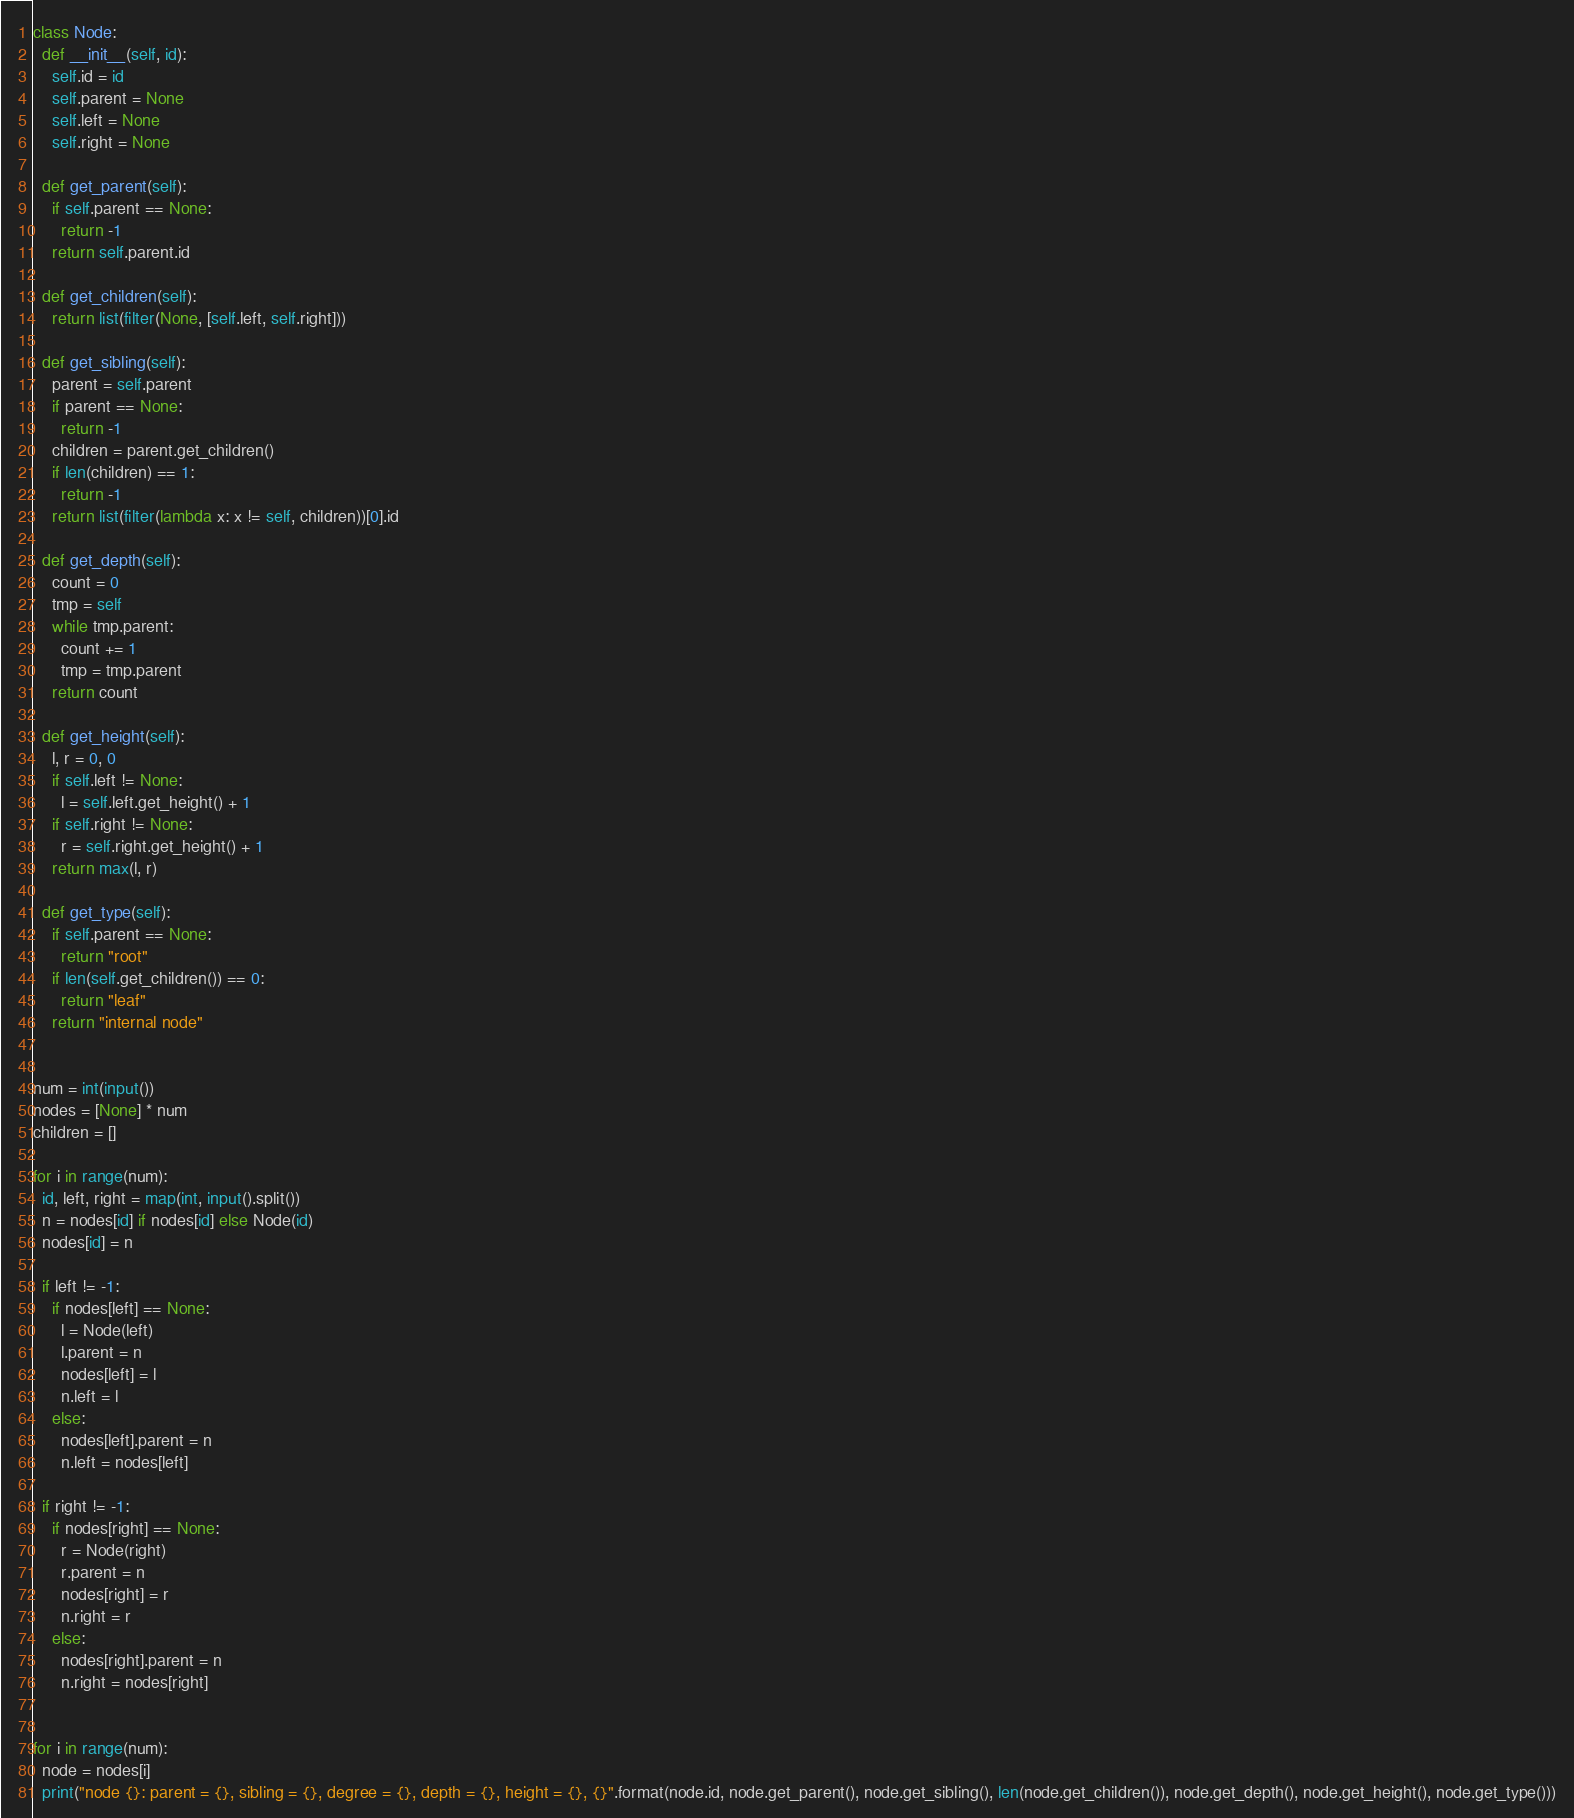Convert code to text. <code><loc_0><loc_0><loc_500><loc_500><_Python_>
class Node:
  def __init__(self, id):
    self.id = id
    self.parent = None
    self.left = None
    self.right = None

  def get_parent(self):
    if self.parent == None:
      return -1
    return self.parent.id

  def get_children(self):
    return list(filter(None, [self.left, self.right]))

  def get_sibling(self):
    parent = self.parent
    if parent == None:
      return -1
    children = parent.get_children()
    if len(children) == 1:
      return -1
    return list(filter(lambda x: x != self, children))[0].id

  def get_depth(self):
    count = 0
    tmp = self
    while tmp.parent:
      count += 1
      tmp = tmp.parent
    return count
    
  def get_height(self):
    l, r = 0, 0
    if self.left != None:
      l = self.left.get_height() + 1
    if self.right != None:
      r = self.right.get_height() + 1
    return max(l, r)
  
  def get_type(self):
    if self.parent == None:
      return "root"
    if len(self.get_children()) == 0:
      return "leaf"
    return "internal node"


num = int(input())
nodes = [None] * num
children = []

for i in range(num):
  id, left, right = map(int, input().split())
  n = nodes[id] if nodes[id] else Node(id)
  nodes[id] = n

  if left != -1:
    if nodes[left] == None:
      l = Node(left)
      l.parent = n
      nodes[left] = l
      n.left = l
    else:
      nodes[left].parent = n
      n.left = nodes[left]

  if right != -1:
    if nodes[right] == None:
      r = Node(right)
      r.parent = n
      nodes[right] = r
      n.right = r
    else:
      nodes[right].parent = n
      n.right = nodes[right]
    

for i in range(num):
  node = nodes[i]
  print("node {}: parent = {}, sibling = {}, degree = {}, depth = {}, height = {}, {}".format(node.id, node.get_parent(), node.get_sibling(), len(node.get_children()), node.get_depth(), node.get_height(), node.get_type()))

</code> 